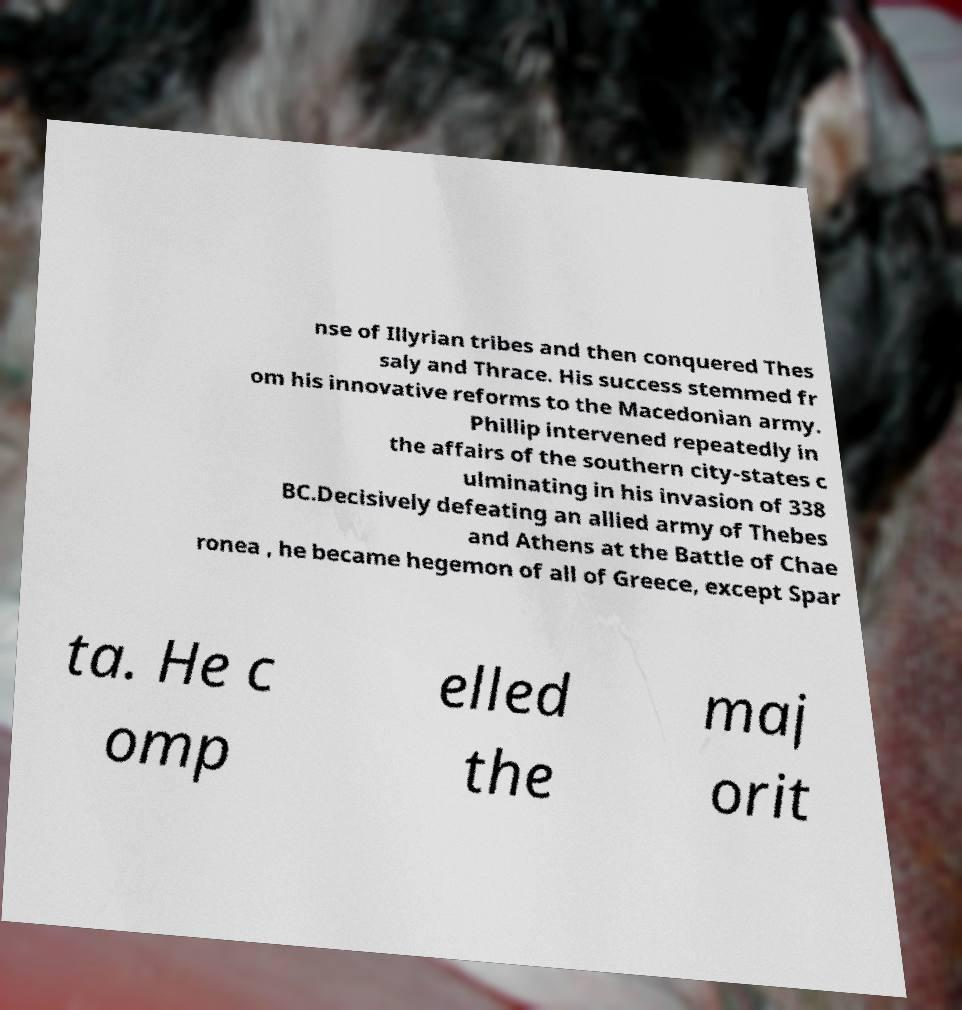Please identify and transcribe the text found in this image. nse of Illyrian tribes and then conquered Thes saly and Thrace. His success stemmed fr om his innovative reforms to the Macedonian army. Phillip intervened repeatedly in the affairs of the southern city-states c ulminating in his invasion of 338 BC.Decisively defeating an allied army of Thebes and Athens at the Battle of Chae ronea , he became hegemon of all of Greece, except Spar ta. He c omp elled the maj orit 